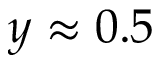<formula> <loc_0><loc_0><loc_500><loc_500>y \approx 0 . 5</formula> 